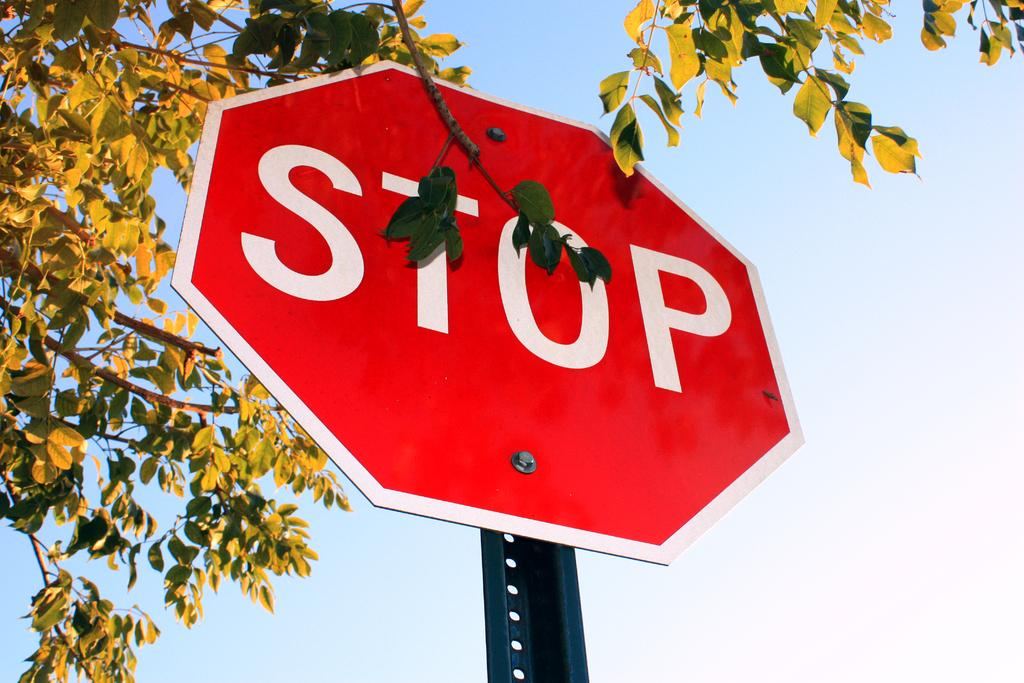<image>
Present a compact description of the photo's key features. red stop sign under a tree on a clear day 